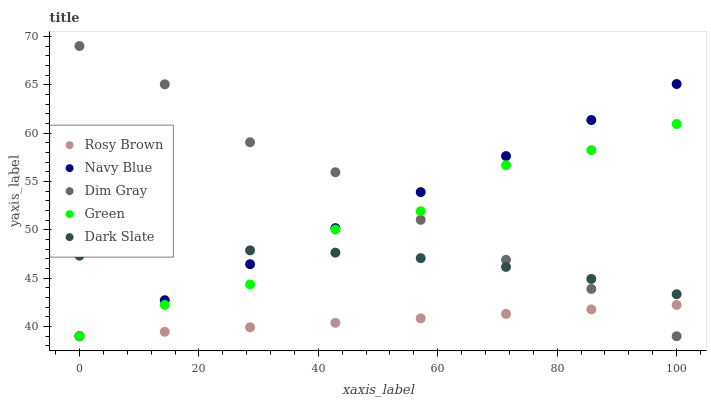Does Rosy Brown have the minimum area under the curve?
Answer yes or no. Yes. Does Dim Gray have the maximum area under the curve?
Answer yes or no. Yes. Does Dim Gray have the minimum area under the curve?
Answer yes or no. No. Does Rosy Brown have the maximum area under the curve?
Answer yes or no. No. Is Rosy Brown the smoothest?
Answer yes or no. Yes. Is Green the roughest?
Answer yes or no. Yes. Is Dim Gray the smoothest?
Answer yes or no. No. Is Dim Gray the roughest?
Answer yes or no. No. Does Navy Blue have the lowest value?
Answer yes or no. Yes. Does Dark Slate have the lowest value?
Answer yes or no. No. Does Dim Gray have the highest value?
Answer yes or no. Yes. Does Rosy Brown have the highest value?
Answer yes or no. No. Is Rosy Brown less than Dark Slate?
Answer yes or no. Yes. Is Dark Slate greater than Rosy Brown?
Answer yes or no. Yes. Does Rosy Brown intersect Navy Blue?
Answer yes or no. Yes. Is Rosy Brown less than Navy Blue?
Answer yes or no. No. Is Rosy Brown greater than Navy Blue?
Answer yes or no. No. Does Rosy Brown intersect Dark Slate?
Answer yes or no. No. 